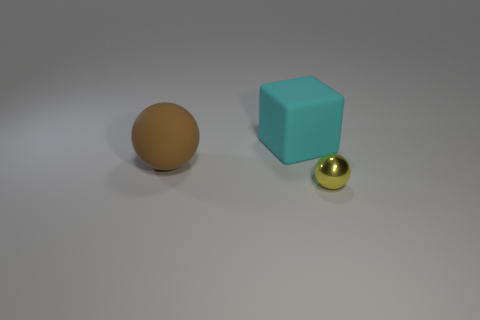Are there fewer rubber things that are behind the large cyan rubber object than big blue matte blocks?
Keep it short and to the point. No. How many metal objects are cyan things or red cylinders?
Ensure brevity in your answer.  0. Is there anything else that is the same size as the yellow metal ball?
Give a very brief answer. No. There is a large sphere that is made of the same material as the cyan block; what color is it?
Ensure brevity in your answer.  Brown. How many cylinders are tiny gray metallic objects or matte things?
Provide a succinct answer. 0. How many things are red matte things or objects that are to the right of the big cube?
Provide a succinct answer. 1. Is there a big brown matte thing?
Your answer should be compact. Yes. There is a metallic object in front of the sphere to the left of the shiny ball; how big is it?
Give a very brief answer. Small. Is there a big cyan block that has the same material as the big brown ball?
Give a very brief answer. Yes. What is the material of the other thing that is the same size as the brown matte thing?
Keep it short and to the point. Rubber. 